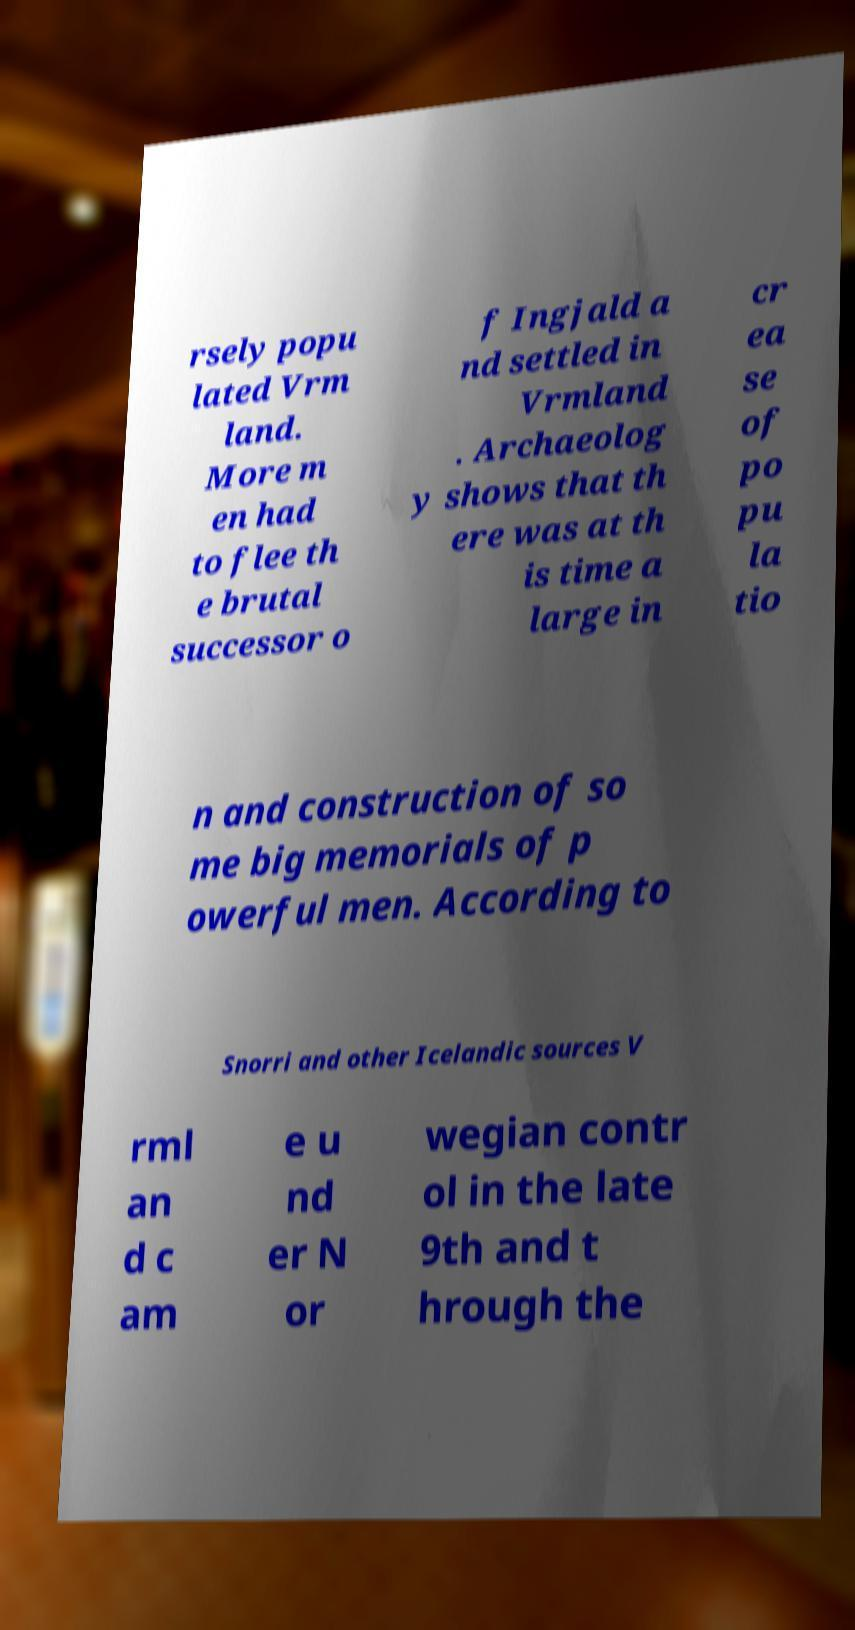Please read and relay the text visible in this image. What does it say? rsely popu lated Vrm land. More m en had to flee th e brutal successor o f Ingjald a nd settled in Vrmland . Archaeolog y shows that th ere was at th is time a large in cr ea se of po pu la tio n and construction of so me big memorials of p owerful men. According to Snorri and other Icelandic sources V rml an d c am e u nd er N or wegian contr ol in the late 9th and t hrough the 